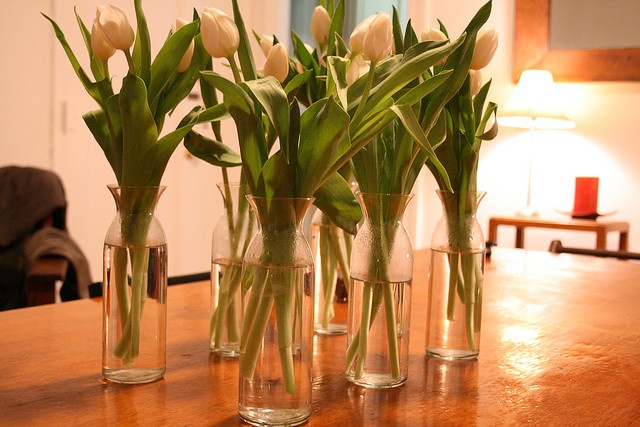Describe the objects in this image and their specific colors. I can see dining table in tan, orange, red, brown, and ivory tones, vase in tan, brown, olive, and maroon tones, vase in tan, brown, and maroon tones, vase in tan and olive tones, and vase in tan, orange, and olive tones in this image. 